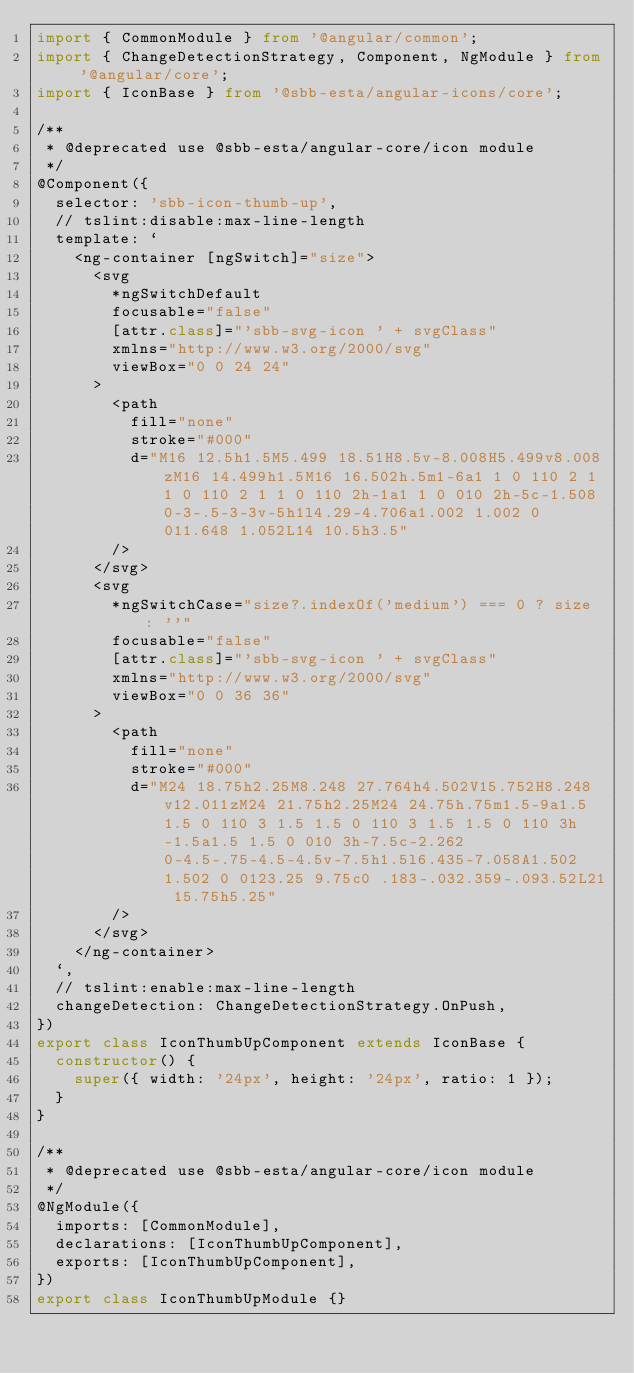<code> <loc_0><loc_0><loc_500><loc_500><_TypeScript_>import { CommonModule } from '@angular/common';
import { ChangeDetectionStrategy, Component, NgModule } from '@angular/core';
import { IconBase } from '@sbb-esta/angular-icons/core';

/**
 * @deprecated use @sbb-esta/angular-core/icon module
 */
@Component({
  selector: 'sbb-icon-thumb-up',
  // tslint:disable:max-line-length
  template: `
    <ng-container [ngSwitch]="size">
      <svg
        *ngSwitchDefault
        focusable="false"
        [attr.class]="'sbb-svg-icon ' + svgClass"
        xmlns="http://www.w3.org/2000/svg"
        viewBox="0 0 24 24"
      >
        <path
          fill="none"
          stroke="#000"
          d="M16 12.5h1.5M5.499 18.51H8.5v-8.008H5.499v8.008zM16 14.499h1.5M16 16.502h.5m1-6a1 1 0 110 2 1 1 0 110 2 1 1 0 110 2h-1a1 1 0 010 2h-5c-1.508 0-3-.5-3-3v-5h1l4.29-4.706a1.002 1.002 0 011.648 1.052L14 10.5h3.5"
        />
      </svg>
      <svg
        *ngSwitchCase="size?.indexOf('medium') === 0 ? size : ''"
        focusable="false"
        [attr.class]="'sbb-svg-icon ' + svgClass"
        xmlns="http://www.w3.org/2000/svg"
        viewBox="0 0 36 36"
      >
        <path
          fill="none"
          stroke="#000"
          d="M24 18.75h2.25M8.248 27.764h4.502V15.752H8.248v12.011zM24 21.75h2.25M24 24.75h.75m1.5-9a1.5 1.5 0 110 3 1.5 1.5 0 110 3 1.5 1.5 0 110 3h-1.5a1.5 1.5 0 010 3h-7.5c-2.262 0-4.5-.75-4.5-4.5v-7.5h1.5l6.435-7.058A1.502 1.502 0 0123.25 9.75c0 .183-.032.359-.093.52L21 15.75h5.25"
        />
      </svg>
    </ng-container>
  `,
  // tslint:enable:max-line-length
  changeDetection: ChangeDetectionStrategy.OnPush,
})
export class IconThumbUpComponent extends IconBase {
  constructor() {
    super({ width: '24px', height: '24px', ratio: 1 });
  }
}

/**
 * @deprecated use @sbb-esta/angular-core/icon module
 */
@NgModule({
  imports: [CommonModule],
  declarations: [IconThumbUpComponent],
  exports: [IconThumbUpComponent],
})
export class IconThumbUpModule {}
</code> 